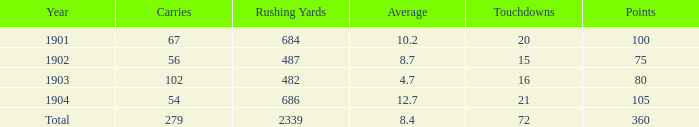What is the cumulative rushing yards for averages above 8.4 and less than 54 carries? 0.0. 